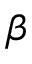Convert formula to latex. <formula><loc_0><loc_0><loc_500><loc_500>\beta</formula> 